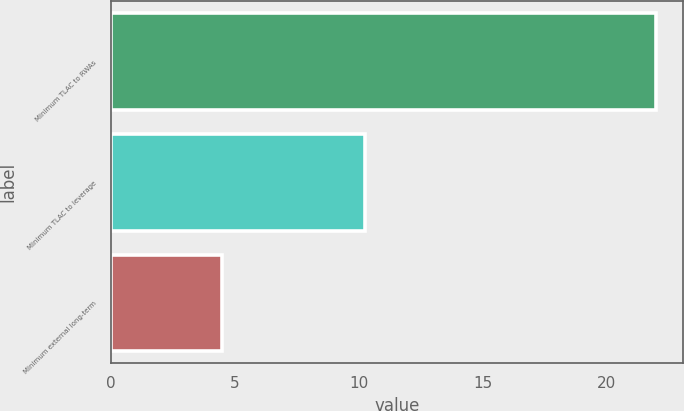Convert chart to OTSL. <chart><loc_0><loc_0><loc_500><loc_500><bar_chart><fcel>Minimum TLAC to RWAs<fcel>Minimum TLAC to leverage<fcel>Minimum external long-term<nl><fcel>22<fcel>10.25<fcel>4.5<nl></chart> 